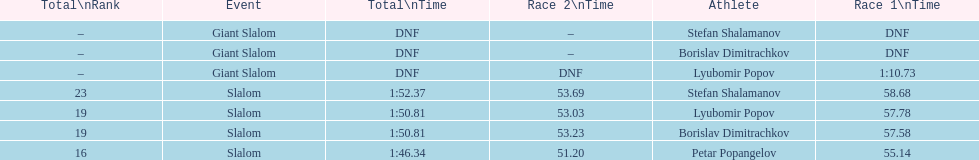Would you mind parsing the complete table? {'header': ['Total\\nRank', 'Event', 'Total\\nTime', 'Race 2\\nTime', 'Athlete', 'Race 1\\nTime'], 'rows': [['–', 'Giant Slalom', 'DNF', '–', 'Stefan Shalamanov', 'DNF'], ['–', 'Giant Slalom', 'DNF', '–', 'Borislav Dimitrachkov', 'DNF'], ['–', 'Giant Slalom', 'DNF', 'DNF', 'Lyubomir Popov', '1:10.73'], ['23', 'Slalom', '1:52.37', '53.69', 'Stefan Shalamanov', '58.68'], ['19', 'Slalom', '1:50.81', '53.03', 'Lyubomir Popov', '57.78'], ['19', 'Slalom', '1:50.81', '53.23', 'Borislav Dimitrachkov', '57.58'], ['16', 'Slalom', '1:46.34', '51.20', 'Petar Popangelov', '55.14']]} What is the rank number of stefan shalamanov in the slalom event 23. 